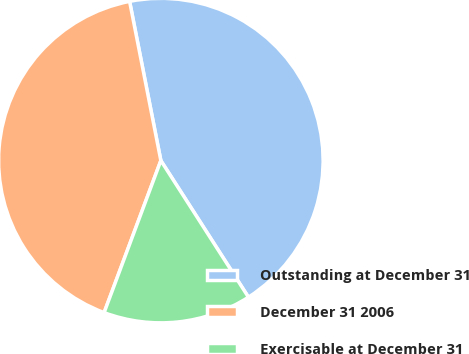Convert chart. <chart><loc_0><loc_0><loc_500><loc_500><pie_chart><fcel>Outstanding at December 31<fcel>December 31 2006<fcel>Exercisable at December 31<nl><fcel>44.01%<fcel>41.23%<fcel>14.76%<nl></chart> 